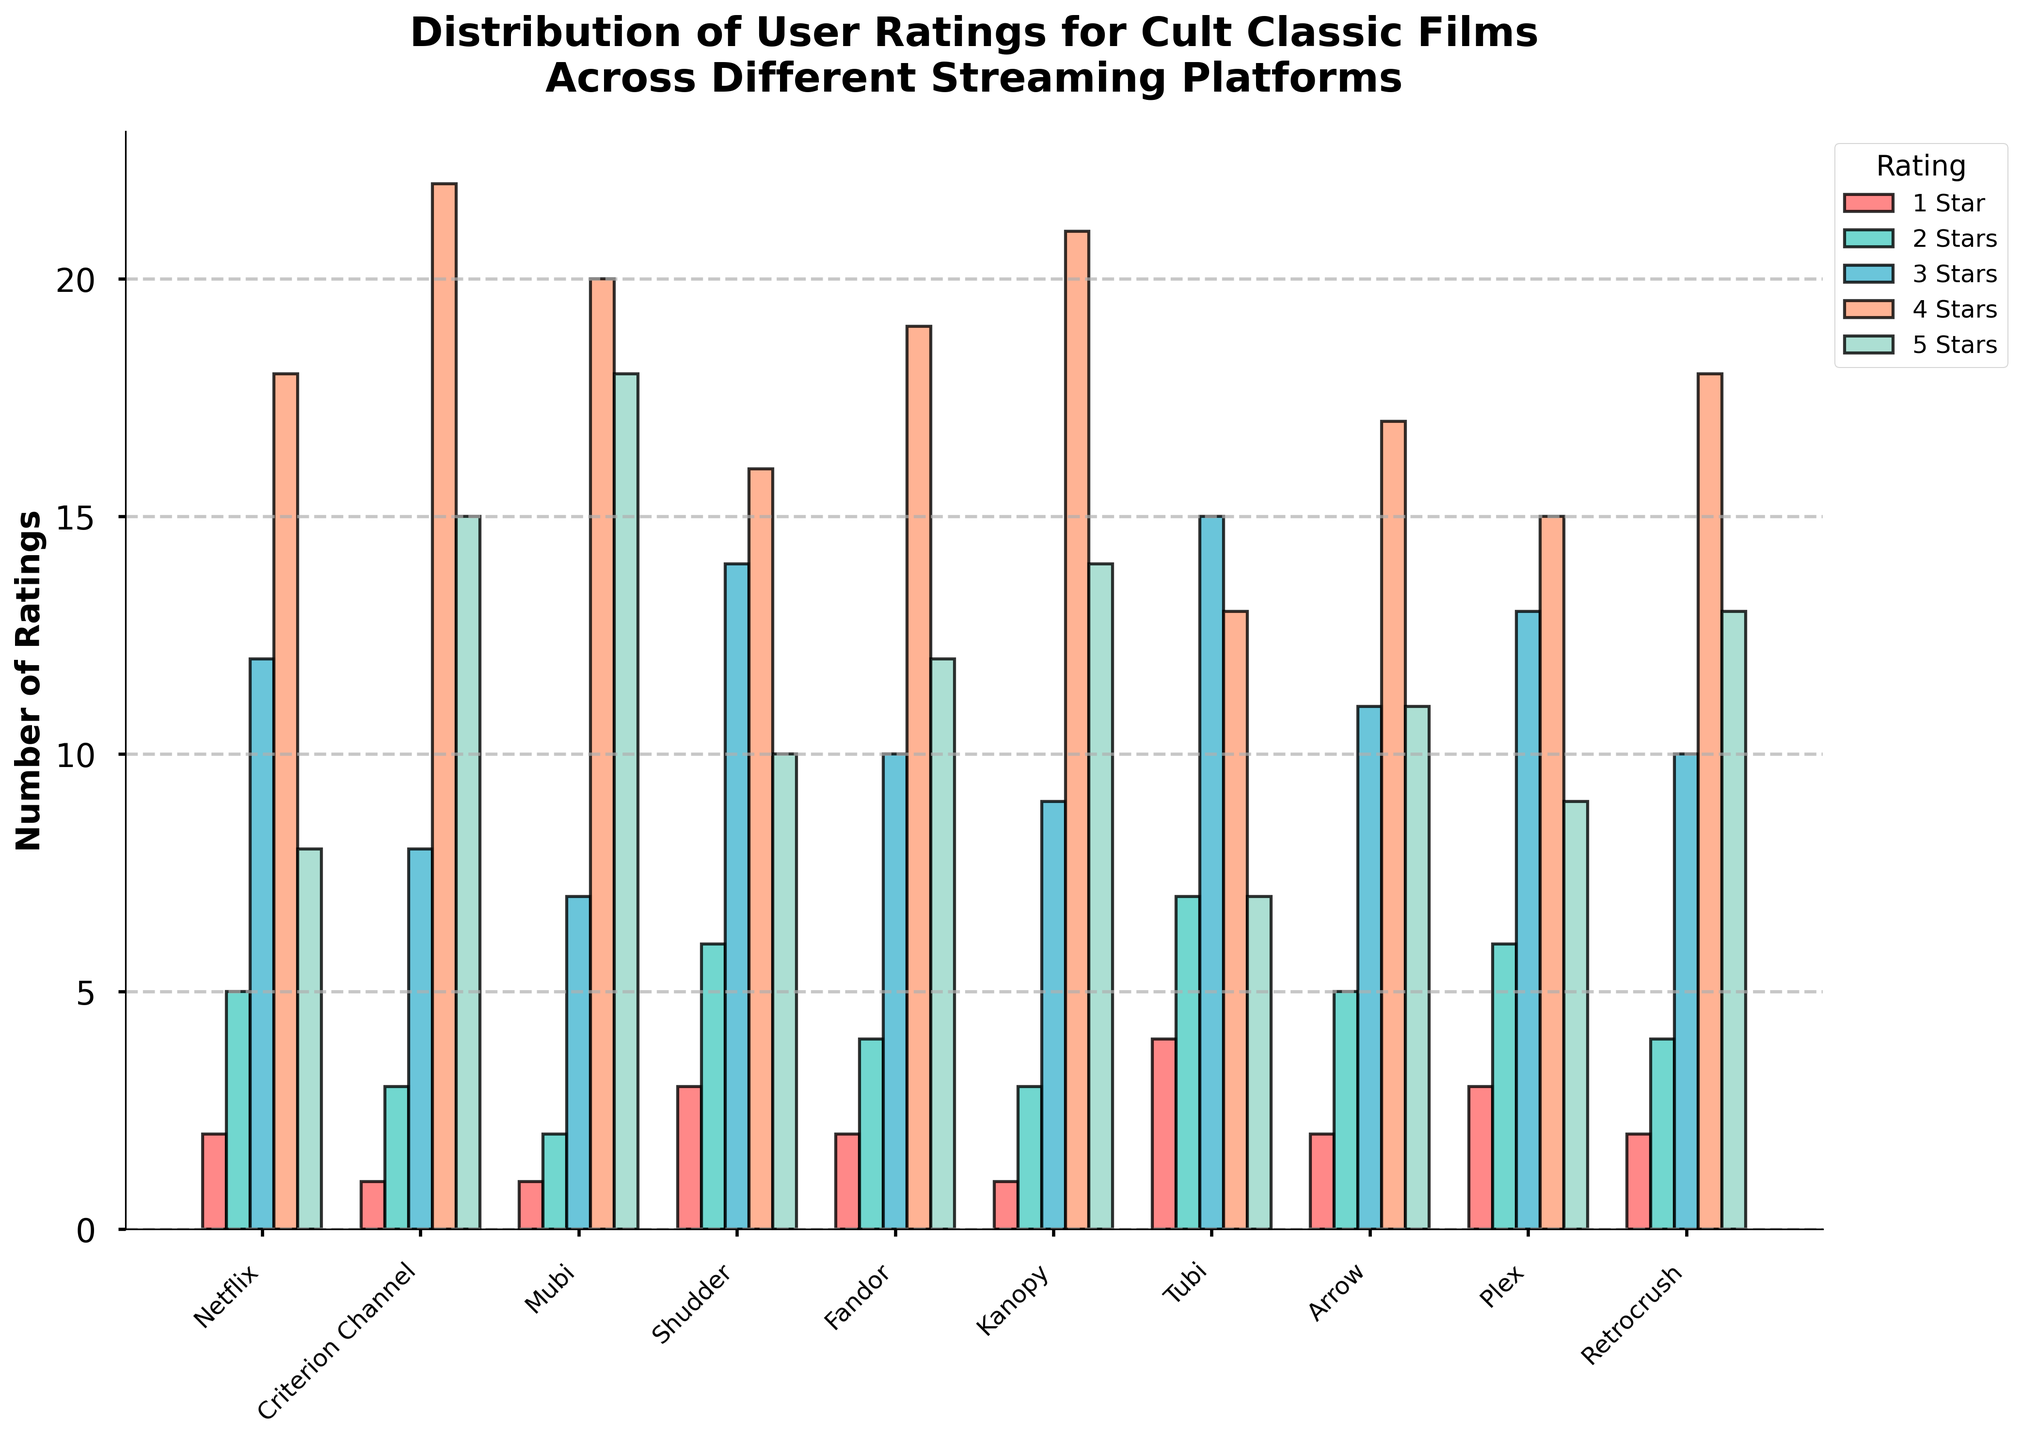Which streaming platform received the highest number of 5-star ratings? Look across the bar chart for the highest bar in the "5 Stars" category. Mubi has the tallest 5-star rating bar with a count of 18
Answer: Mubi Which platform has the most 1-star ratings? Across the "1 Star" category, compare the heights of the bars. Tubi has the tallest bar with 4 ratings.
Answer: Tubi Which two platforms have almost equal 4-star ratings, and what are their values? Look across the "4 Stars" category to find bars of nearly equal height. Kanopy and Retrocrush both appear similar, each having 21 and 18 ratings, respectively.
Answer: Kanopy, Retrocrush, 21 and 18 What is the total number of 2-star ratings across all platforms? Sum the number of 2-star ratings for all platforms: 5 + 3 + 2 + 6 + 4 + 3 + 7 + 5 + 6 + 4. This equals 45.
Answer: 45 What is the average number of ratings (across all ratings) for Criterion Channel? Sum the number of ratings for each star category for Criterion Channel: 1 + 3 + 8 + 22 + 15 equals 49. Divide by 5 categories to get the average: 49 / 5 = 9.8.
Answer: 9.8 For which rating is there the smallest difference in the number of ratings between Arrow and Plex? Compare the ratings for each star category between Arrow and Plex: 
1-star: 2 vs. 3 (difference of 1),
2 stars: 5 vs. 6 (difference of 1),
3 stars: 11 vs. 13 (difference of 2),
4 stars: 17 vs. 15 (difference of 2),
5 stars: 11 vs. 9 (difference of 2).
The smallest difference is for 1-star and 2-star ratings (1 each)
Answer: 1-star and 2-star Which platform has the greater number of 3-star ratings, Fandor or Shudder? Compare the heights of the bars for the 3-star category. Fandor has a bar with 10 ratings and Shudder has 14. So Shudder has more 3-star ratings.
Answer: Shudder What is the sum of 4-star and 5-star ratings for Kanopy? Add the counts of 4-star and 5-star ratings for Kanopy: 21 + 14 = 35
Answer: 35 Which streaming platforms have more than 15 ratings in the 4-star category? Scan the chart and identify platforms with bars exceeding 15 in the 4-star category. Criterion Channel (22), Fandor (19), Kanopy (21), Retrocrush (18), and Arrow (17) are above 15.
Answer: Criterion Channel, Fandor, Kanopy, Retrocrush, Arrow Across all platforms, which rating star category consistently shows an increase in the number of ratings? Observe if there's a collective increase across platforms from 1 star to 5 stars. Only the 4-star category has consistently high numbers across most platforms, indicating general favorability.
Answer: 4 Stars 